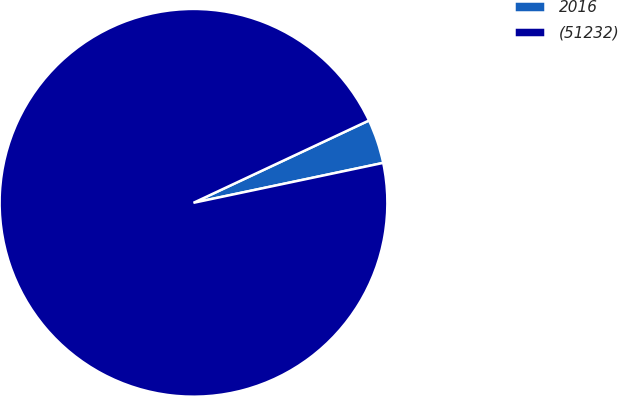Convert chart. <chart><loc_0><loc_0><loc_500><loc_500><pie_chart><fcel>2016<fcel>(51232)<nl><fcel>3.68%<fcel>96.32%<nl></chart> 